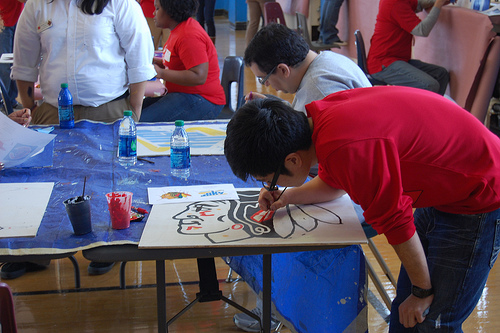<image>
Is the water bottle behind the cup? Yes. From this viewpoint, the water bottle is positioned behind the cup, with the cup partially or fully occluding the water bottle. 